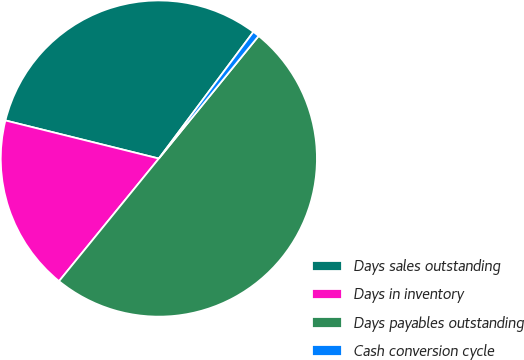Convert chart. <chart><loc_0><loc_0><loc_500><loc_500><pie_chart><fcel>Days sales outstanding<fcel>Days in inventory<fcel>Days payables outstanding<fcel>Cash conversion cycle<nl><fcel>31.33%<fcel>18.0%<fcel>50.0%<fcel>0.67%<nl></chart> 